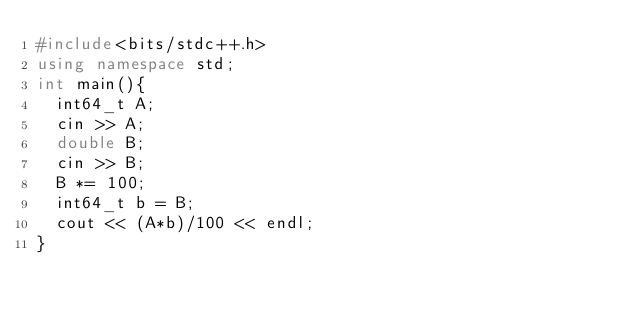<code> <loc_0><loc_0><loc_500><loc_500><_C++_>#include<bits/stdc++.h>
using namespace std;
int main(){
  int64_t A;
  cin >> A;
  double B;
  cin >> B;
  B *= 100;
  int64_t b = B;
  cout << (A*b)/100 << endl;
}</code> 